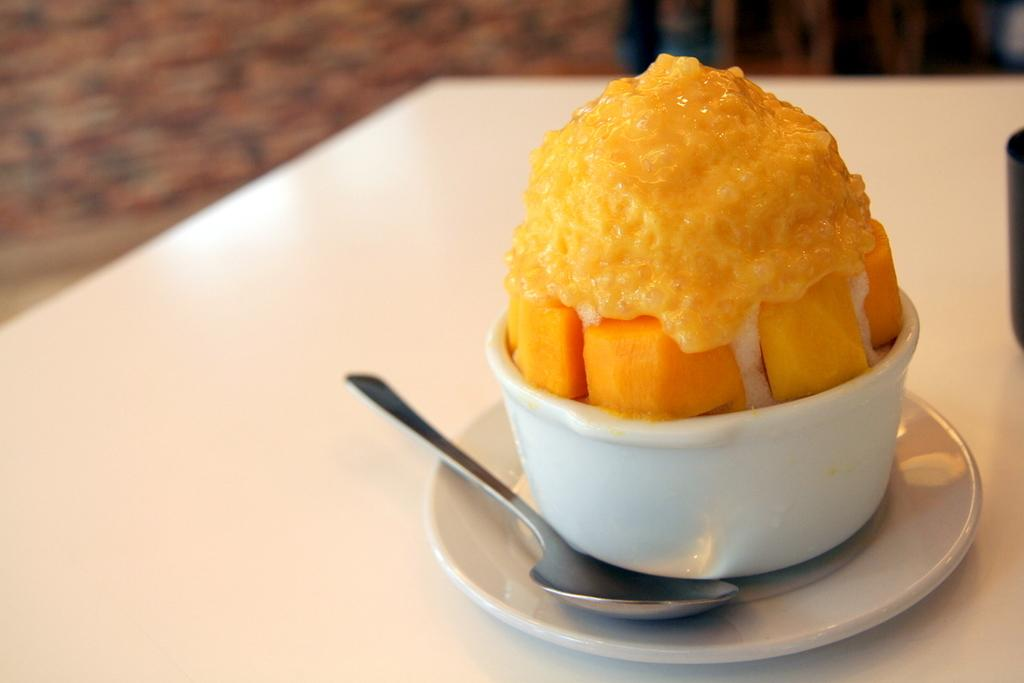What is in the bowl that is visible in the image? There is a food item in a bowl in the image. What utensil is visible in the image? There is a spoon visible in the image. What surface is the bowl and spoon placed on in the image? There is a plate on the table in the image. Can you tell me how many snakes are on the plate in the image? There are no snakes present in the image; it features a bowl of food, a spoon, and a plate on a table. 